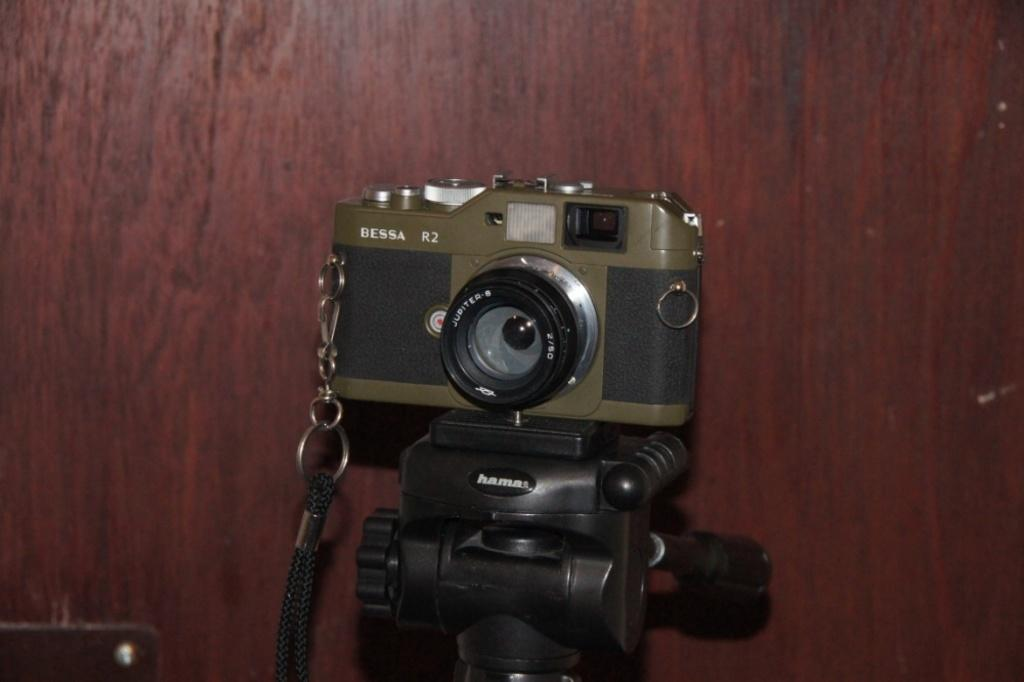What is the main object in the image? There is a camera in the image. How is the camera positioned in the image? The camera is placed on a stand. How many cakes are being photographed by the camera in the image? There are no cakes present in the image; it only features a camera on a stand. What is the current temperature in the image? The image does not provide information about the temperature or weather conditions. 